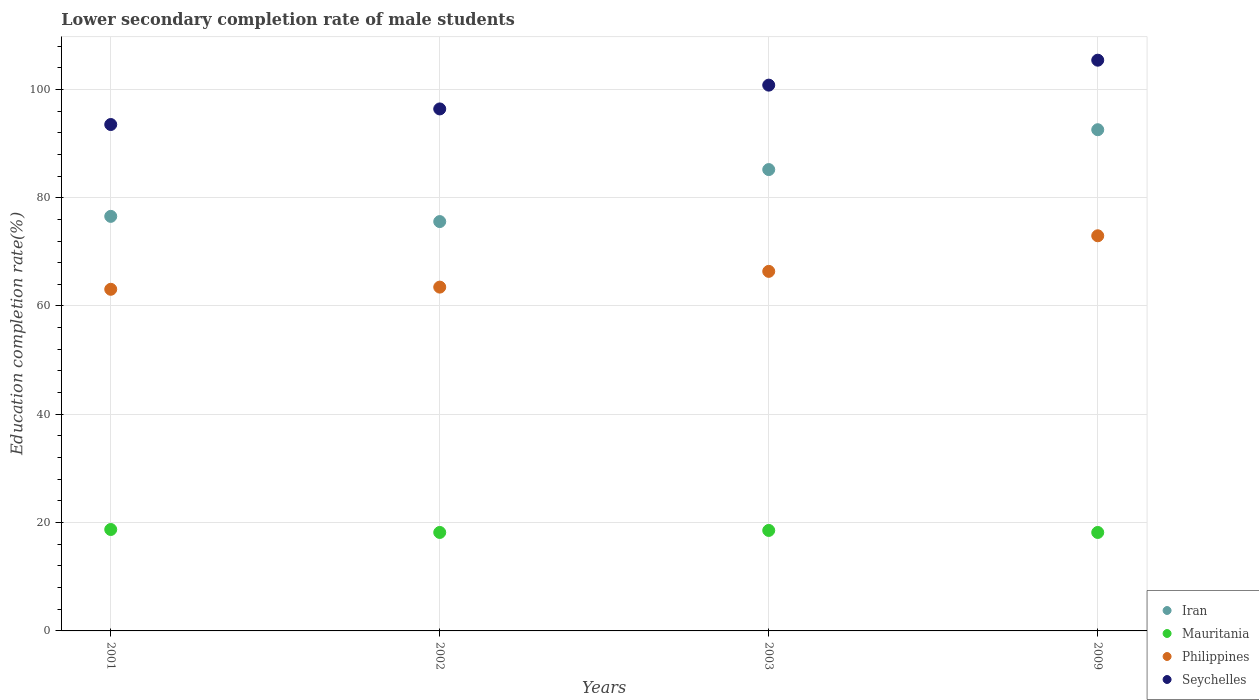Is the number of dotlines equal to the number of legend labels?
Ensure brevity in your answer.  Yes. What is the lower secondary completion rate of male students in Iran in 2002?
Offer a very short reply. 75.59. Across all years, what is the maximum lower secondary completion rate of male students in Iran?
Your response must be concise. 92.55. Across all years, what is the minimum lower secondary completion rate of male students in Iran?
Give a very brief answer. 75.59. In which year was the lower secondary completion rate of male students in Mauritania maximum?
Your response must be concise. 2001. What is the total lower secondary completion rate of male students in Mauritania in the graph?
Provide a succinct answer. 73.65. What is the difference between the lower secondary completion rate of male students in Seychelles in 2002 and that in 2003?
Ensure brevity in your answer.  -4.39. What is the difference between the lower secondary completion rate of male students in Philippines in 2001 and the lower secondary completion rate of male students in Mauritania in 2009?
Offer a very short reply. 44.9. What is the average lower secondary completion rate of male students in Philippines per year?
Ensure brevity in your answer.  66.48. In the year 2001, what is the difference between the lower secondary completion rate of male students in Mauritania and lower secondary completion rate of male students in Philippines?
Keep it short and to the point. -44.35. In how many years, is the lower secondary completion rate of male students in Seychelles greater than 84 %?
Your answer should be very brief. 4. What is the ratio of the lower secondary completion rate of male students in Mauritania in 2002 to that in 2009?
Make the answer very short. 1. Is the difference between the lower secondary completion rate of male students in Mauritania in 2002 and 2003 greater than the difference between the lower secondary completion rate of male students in Philippines in 2002 and 2003?
Provide a succinct answer. Yes. What is the difference between the highest and the second highest lower secondary completion rate of male students in Seychelles?
Offer a very short reply. 4.61. What is the difference between the highest and the lowest lower secondary completion rate of male students in Seychelles?
Provide a short and direct response. 11.88. In how many years, is the lower secondary completion rate of male students in Iran greater than the average lower secondary completion rate of male students in Iran taken over all years?
Keep it short and to the point. 2. Is it the case that in every year, the sum of the lower secondary completion rate of male students in Philippines and lower secondary completion rate of male students in Iran  is greater than the lower secondary completion rate of male students in Seychelles?
Offer a terse response. Yes. Does the lower secondary completion rate of male students in Iran monotonically increase over the years?
Your answer should be compact. No. Is the lower secondary completion rate of male students in Iran strictly greater than the lower secondary completion rate of male students in Mauritania over the years?
Offer a very short reply. Yes. Is the lower secondary completion rate of male students in Mauritania strictly less than the lower secondary completion rate of male students in Philippines over the years?
Provide a succinct answer. Yes. How many years are there in the graph?
Your response must be concise. 4. Does the graph contain any zero values?
Provide a succinct answer. No. Where does the legend appear in the graph?
Provide a succinct answer. Bottom right. How many legend labels are there?
Offer a very short reply. 4. What is the title of the graph?
Your answer should be very brief. Lower secondary completion rate of male students. What is the label or title of the X-axis?
Give a very brief answer. Years. What is the label or title of the Y-axis?
Your answer should be compact. Education completion rate(%). What is the Education completion rate(%) in Iran in 2001?
Keep it short and to the point. 76.55. What is the Education completion rate(%) of Mauritania in 2001?
Provide a succinct answer. 18.73. What is the Education completion rate(%) in Philippines in 2001?
Your response must be concise. 63.08. What is the Education completion rate(%) in Seychelles in 2001?
Your answer should be compact. 93.51. What is the Education completion rate(%) of Iran in 2002?
Offer a very short reply. 75.59. What is the Education completion rate(%) of Mauritania in 2002?
Provide a succinct answer. 18.18. What is the Education completion rate(%) in Philippines in 2002?
Keep it short and to the point. 63.49. What is the Education completion rate(%) in Seychelles in 2002?
Offer a very short reply. 96.39. What is the Education completion rate(%) of Iran in 2003?
Make the answer very short. 85.19. What is the Education completion rate(%) in Mauritania in 2003?
Your response must be concise. 18.56. What is the Education completion rate(%) of Philippines in 2003?
Provide a short and direct response. 66.39. What is the Education completion rate(%) of Seychelles in 2003?
Offer a very short reply. 100.78. What is the Education completion rate(%) of Iran in 2009?
Provide a short and direct response. 92.55. What is the Education completion rate(%) of Mauritania in 2009?
Make the answer very short. 18.18. What is the Education completion rate(%) of Philippines in 2009?
Give a very brief answer. 72.97. What is the Education completion rate(%) in Seychelles in 2009?
Offer a very short reply. 105.39. Across all years, what is the maximum Education completion rate(%) in Iran?
Your response must be concise. 92.55. Across all years, what is the maximum Education completion rate(%) in Mauritania?
Your answer should be very brief. 18.73. Across all years, what is the maximum Education completion rate(%) of Philippines?
Make the answer very short. 72.97. Across all years, what is the maximum Education completion rate(%) of Seychelles?
Offer a terse response. 105.39. Across all years, what is the minimum Education completion rate(%) of Iran?
Your response must be concise. 75.59. Across all years, what is the minimum Education completion rate(%) of Mauritania?
Your response must be concise. 18.18. Across all years, what is the minimum Education completion rate(%) of Philippines?
Provide a succinct answer. 63.08. Across all years, what is the minimum Education completion rate(%) of Seychelles?
Ensure brevity in your answer.  93.51. What is the total Education completion rate(%) of Iran in the graph?
Provide a short and direct response. 329.88. What is the total Education completion rate(%) of Mauritania in the graph?
Offer a very short reply. 73.65. What is the total Education completion rate(%) of Philippines in the graph?
Your answer should be compact. 265.93. What is the total Education completion rate(%) in Seychelles in the graph?
Ensure brevity in your answer.  396.08. What is the difference between the Education completion rate(%) of Iran in 2001 and that in 2002?
Ensure brevity in your answer.  0.96. What is the difference between the Education completion rate(%) in Mauritania in 2001 and that in 2002?
Provide a succinct answer. 0.55. What is the difference between the Education completion rate(%) in Philippines in 2001 and that in 2002?
Ensure brevity in your answer.  -0.4. What is the difference between the Education completion rate(%) of Seychelles in 2001 and that in 2002?
Your response must be concise. -2.88. What is the difference between the Education completion rate(%) of Iran in 2001 and that in 2003?
Keep it short and to the point. -8.64. What is the difference between the Education completion rate(%) of Mauritania in 2001 and that in 2003?
Your answer should be compact. 0.17. What is the difference between the Education completion rate(%) of Philippines in 2001 and that in 2003?
Ensure brevity in your answer.  -3.31. What is the difference between the Education completion rate(%) of Seychelles in 2001 and that in 2003?
Your answer should be very brief. -7.27. What is the difference between the Education completion rate(%) in Iran in 2001 and that in 2009?
Provide a succinct answer. -16. What is the difference between the Education completion rate(%) in Mauritania in 2001 and that in 2009?
Keep it short and to the point. 0.55. What is the difference between the Education completion rate(%) of Philippines in 2001 and that in 2009?
Your answer should be compact. -9.88. What is the difference between the Education completion rate(%) of Seychelles in 2001 and that in 2009?
Provide a short and direct response. -11.88. What is the difference between the Education completion rate(%) of Iran in 2002 and that in 2003?
Ensure brevity in your answer.  -9.6. What is the difference between the Education completion rate(%) in Mauritania in 2002 and that in 2003?
Offer a very short reply. -0.37. What is the difference between the Education completion rate(%) of Philippines in 2002 and that in 2003?
Your answer should be compact. -2.91. What is the difference between the Education completion rate(%) in Seychelles in 2002 and that in 2003?
Keep it short and to the point. -4.39. What is the difference between the Education completion rate(%) of Iran in 2002 and that in 2009?
Offer a very short reply. -16.96. What is the difference between the Education completion rate(%) of Mauritania in 2002 and that in 2009?
Ensure brevity in your answer.  0. What is the difference between the Education completion rate(%) of Philippines in 2002 and that in 2009?
Give a very brief answer. -9.48. What is the difference between the Education completion rate(%) of Seychelles in 2002 and that in 2009?
Make the answer very short. -9. What is the difference between the Education completion rate(%) in Iran in 2003 and that in 2009?
Make the answer very short. -7.36. What is the difference between the Education completion rate(%) of Mauritania in 2003 and that in 2009?
Provide a short and direct response. 0.38. What is the difference between the Education completion rate(%) in Philippines in 2003 and that in 2009?
Offer a terse response. -6.57. What is the difference between the Education completion rate(%) of Seychelles in 2003 and that in 2009?
Provide a succinct answer. -4.61. What is the difference between the Education completion rate(%) of Iran in 2001 and the Education completion rate(%) of Mauritania in 2002?
Give a very brief answer. 58.37. What is the difference between the Education completion rate(%) in Iran in 2001 and the Education completion rate(%) in Philippines in 2002?
Make the answer very short. 13.06. What is the difference between the Education completion rate(%) in Iran in 2001 and the Education completion rate(%) in Seychelles in 2002?
Offer a very short reply. -19.84. What is the difference between the Education completion rate(%) in Mauritania in 2001 and the Education completion rate(%) in Philippines in 2002?
Your answer should be very brief. -44.76. What is the difference between the Education completion rate(%) of Mauritania in 2001 and the Education completion rate(%) of Seychelles in 2002?
Your response must be concise. -77.66. What is the difference between the Education completion rate(%) in Philippines in 2001 and the Education completion rate(%) in Seychelles in 2002?
Your response must be concise. -33.31. What is the difference between the Education completion rate(%) in Iran in 2001 and the Education completion rate(%) in Mauritania in 2003?
Provide a succinct answer. 58. What is the difference between the Education completion rate(%) of Iran in 2001 and the Education completion rate(%) of Philippines in 2003?
Provide a short and direct response. 10.16. What is the difference between the Education completion rate(%) in Iran in 2001 and the Education completion rate(%) in Seychelles in 2003?
Provide a short and direct response. -24.23. What is the difference between the Education completion rate(%) of Mauritania in 2001 and the Education completion rate(%) of Philippines in 2003?
Provide a succinct answer. -47.66. What is the difference between the Education completion rate(%) of Mauritania in 2001 and the Education completion rate(%) of Seychelles in 2003?
Ensure brevity in your answer.  -82.06. What is the difference between the Education completion rate(%) of Philippines in 2001 and the Education completion rate(%) of Seychelles in 2003?
Your response must be concise. -37.7. What is the difference between the Education completion rate(%) of Iran in 2001 and the Education completion rate(%) of Mauritania in 2009?
Provide a succinct answer. 58.37. What is the difference between the Education completion rate(%) of Iran in 2001 and the Education completion rate(%) of Philippines in 2009?
Ensure brevity in your answer.  3.58. What is the difference between the Education completion rate(%) of Iran in 2001 and the Education completion rate(%) of Seychelles in 2009?
Your answer should be very brief. -28.84. What is the difference between the Education completion rate(%) in Mauritania in 2001 and the Education completion rate(%) in Philippines in 2009?
Ensure brevity in your answer.  -54.24. What is the difference between the Education completion rate(%) of Mauritania in 2001 and the Education completion rate(%) of Seychelles in 2009?
Make the answer very short. -86.66. What is the difference between the Education completion rate(%) in Philippines in 2001 and the Education completion rate(%) in Seychelles in 2009?
Provide a succinct answer. -42.31. What is the difference between the Education completion rate(%) of Iran in 2002 and the Education completion rate(%) of Mauritania in 2003?
Offer a terse response. 57.03. What is the difference between the Education completion rate(%) of Iran in 2002 and the Education completion rate(%) of Philippines in 2003?
Offer a very short reply. 9.2. What is the difference between the Education completion rate(%) of Iran in 2002 and the Education completion rate(%) of Seychelles in 2003?
Offer a very short reply. -25.2. What is the difference between the Education completion rate(%) in Mauritania in 2002 and the Education completion rate(%) in Philippines in 2003?
Your answer should be very brief. -48.21. What is the difference between the Education completion rate(%) in Mauritania in 2002 and the Education completion rate(%) in Seychelles in 2003?
Offer a very short reply. -82.6. What is the difference between the Education completion rate(%) in Philippines in 2002 and the Education completion rate(%) in Seychelles in 2003?
Offer a terse response. -37.3. What is the difference between the Education completion rate(%) of Iran in 2002 and the Education completion rate(%) of Mauritania in 2009?
Offer a terse response. 57.41. What is the difference between the Education completion rate(%) in Iran in 2002 and the Education completion rate(%) in Philippines in 2009?
Keep it short and to the point. 2.62. What is the difference between the Education completion rate(%) of Iran in 2002 and the Education completion rate(%) of Seychelles in 2009?
Keep it short and to the point. -29.8. What is the difference between the Education completion rate(%) of Mauritania in 2002 and the Education completion rate(%) of Philippines in 2009?
Give a very brief answer. -54.78. What is the difference between the Education completion rate(%) in Mauritania in 2002 and the Education completion rate(%) in Seychelles in 2009?
Your response must be concise. -87.21. What is the difference between the Education completion rate(%) in Philippines in 2002 and the Education completion rate(%) in Seychelles in 2009?
Ensure brevity in your answer.  -41.9. What is the difference between the Education completion rate(%) of Iran in 2003 and the Education completion rate(%) of Mauritania in 2009?
Provide a succinct answer. 67.01. What is the difference between the Education completion rate(%) in Iran in 2003 and the Education completion rate(%) in Philippines in 2009?
Your answer should be very brief. 12.23. What is the difference between the Education completion rate(%) of Iran in 2003 and the Education completion rate(%) of Seychelles in 2009?
Your answer should be very brief. -20.2. What is the difference between the Education completion rate(%) in Mauritania in 2003 and the Education completion rate(%) in Philippines in 2009?
Give a very brief answer. -54.41. What is the difference between the Education completion rate(%) of Mauritania in 2003 and the Education completion rate(%) of Seychelles in 2009?
Keep it short and to the point. -86.83. What is the difference between the Education completion rate(%) in Philippines in 2003 and the Education completion rate(%) in Seychelles in 2009?
Keep it short and to the point. -39. What is the average Education completion rate(%) in Iran per year?
Your answer should be very brief. 82.47. What is the average Education completion rate(%) in Mauritania per year?
Provide a short and direct response. 18.41. What is the average Education completion rate(%) in Philippines per year?
Keep it short and to the point. 66.48. What is the average Education completion rate(%) of Seychelles per year?
Give a very brief answer. 99.02. In the year 2001, what is the difference between the Education completion rate(%) in Iran and Education completion rate(%) in Mauritania?
Provide a short and direct response. 57.82. In the year 2001, what is the difference between the Education completion rate(%) of Iran and Education completion rate(%) of Philippines?
Provide a short and direct response. 13.47. In the year 2001, what is the difference between the Education completion rate(%) in Iran and Education completion rate(%) in Seychelles?
Provide a short and direct response. -16.96. In the year 2001, what is the difference between the Education completion rate(%) of Mauritania and Education completion rate(%) of Philippines?
Your response must be concise. -44.35. In the year 2001, what is the difference between the Education completion rate(%) in Mauritania and Education completion rate(%) in Seychelles?
Offer a terse response. -74.78. In the year 2001, what is the difference between the Education completion rate(%) in Philippines and Education completion rate(%) in Seychelles?
Give a very brief answer. -30.43. In the year 2002, what is the difference between the Education completion rate(%) of Iran and Education completion rate(%) of Mauritania?
Offer a terse response. 57.41. In the year 2002, what is the difference between the Education completion rate(%) of Iran and Education completion rate(%) of Philippines?
Give a very brief answer. 12.1. In the year 2002, what is the difference between the Education completion rate(%) in Iran and Education completion rate(%) in Seychelles?
Ensure brevity in your answer.  -20.8. In the year 2002, what is the difference between the Education completion rate(%) of Mauritania and Education completion rate(%) of Philippines?
Provide a short and direct response. -45.3. In the year 2002, what is the difference between the Education completion rate(%) in Mauritania and Education completion rate(%) in Seychelles?
Provide a short and direct response. -78.21. In the year 2002, what is the difference between the Education completion rate(%) of Philippines and Education completion rate(%) of Seychelles?
Provide a short and direct response. -32.91. In the year 2003, what is the difference between the Education completion rate(%) of Iran and Education completion rate(%) of Mauritania?
Give a very brief answer. 66.64. In the year 2003, what is the difference between the Education completion rate(%) of Iran and Education completion rate(%) of Philippines?
Your answer should be compact. 18.8. In the year 2003, what is the difference between the Education completion rate(%) of Iran and Education completion rate(%) of Seychelles?
Provide a succinct answer. -15.59. In the year 2003, what is the difference between the Education completion rate(%) of Mauritania and Education completion rate(%) of Philippines?
Provide a succinct answer. -47.84. In the year 2003, what is the difference between the Education completion rate(%) of Mauritania and Education completion rate(%) of Seychelles?
Offer a terse response. -82.23. In the year 2003, what is the difference between the Education completion rate(%) of Philippines and Education completion rate(%) of Seychelles?
Your response must be concise. -34.39. In the year 2009, what is the difference between the Education completion rate(%) in Iran and Education completion rate(%) in Mauritania?
Your answer should be very brief. 74.37. In the year 2009, what is the difference between the Education completion rate(%) in Iran and Education completion rate(%) in Philippines?
Keep it short and to the point. 19.59. In the year 2009, what is the difference between the Education completion rate(%) in Iran and Education completion rate(%) in Seychelles?
Provide a short and direct response. -12.84. In the year 2009, what is the difference between the Education completion rate(%) of Mauritania and Education completion rate(%) of Philippines?
Provide a succinct answer. -54.79. In the year 2009, what is the difference between the Education completion rate(%) in Mauritania and Education completion rate(%) in Seychelles?
Your answer should be very brief. -87.21. In the year 2009, what is the difference between the Education completion rate(%) of Philippines and Education completion rate(%) of Seychelles?
Keep it short and to the point. -32.42. What is the ratio of the Education completion rate(%) in Iran in 2001 to that in 2002?
Your answer should be compact. 1.01. What is the ratio of the Education completion rate(%) of Mauritania in 2001 to that in 2002?
Give a very brief answer. 1.03. What is the ratio of the Education completion rate(%) of Philippines in 2001 to that in 2002?
Provide a short and direct response. 0.99. What is the ratio of the Education completion rate(%) in Seychelles in 2001 to that in 2002?
Provide a succinct answer. 0.97. What is the ratio of the Education completion rate(%) in Iran in 2001 to that in 2003?
Provide a succinct answer. 0.9. What is the ratio of the Education completion rate(%) in Mauritania in 2001 to that in 2003?
Give a very brief answer. 1.01. What is the ratio of the Education completion rate(%) of Philippines in 2001 to that in 2003?
Offer a very short reply. 0.95. What is the ratio of the Education completion rate(%) of Seychelles in 2001 to that in 2003?
Offer a terse response. 0.93. What is the ratio of the Education completion rate(%) in Iran in 2001 to that in 2009?
Provide a short and direct response. 0.83. What is the ratio of the Education completion rate(%) of Mauritania in 2001 to that in 2009?
Your answer should be very brief. 1.03. What is the ratio of the Education completion rate(%) of Philippines in 2001 to that in 2009?
Give a very brief answer. 0.86. What is the ratio of the Education completion rate(%) of Seychelles in 2001 to that in 2009?
Offer a terse response. 0.89. What is the ratio of the Education completion rate(%) of Iran in 2002 to that in 2003?
Give a very brief answer. 0.89. What is the ratio of the Education completion rate(%) of Mauritania in 2002 to that in 2003?
Give a very brief answer. 0.98. What is the ratio of the Education completion rate(%) in Philippines in 2002 to that in 2003?
Your answer should be very brief. 0.96. What is the ratio of the Education completion rate(%) of Seychelles in 2002 to that in 2003?
Ensure brevity in your answer.  0.96. What is the ratio of the Education completion rate(%) in Iran in 2002 to that in 2009?
Offer a terse response. 0.82. What is the ratio of the Education completion rate(%) in Mauritania in 2002 to that in 2009?
Your answer should be very brief. 1. What is the ratio of the Education completion rate(%) in Philippines in 2002 to that in 2009?
Make the answer very short. 0.87. What is the ratio of the Education completion rate(%) in Seychelles in 2002 to that in 2009?
Your answer should be very brief. 0.91. What is the ratio of the Education completion rate(%) in Iran in 2003 to that in 2009?
Offer a terse response. 0.92. What is the ratio of the Education completion rate(%) in Mauritania in 2003 to that in 2009?
Ensure brevity in your answer.  1.02. What is the ratio of the Education completion rate(%) in Philippines in 2003 to that in 2009?
Your response must be concise. 0.91. What is the ratio of the Education completion rate(%) in Seychelles in 2003 to that in 2009?
Keep it short and to the point. 0.96. What is the difference between the highest and the second highest Education completion rate(%) in Iran?
Offer a terse response. 7.36. What is the difference between the highest and the second highest Education completion rate(%) in Mauritania?
Give a very brief answer. 0.17. What is the difference between the highest and the second highest Education completion rate(%) of Philippines?
Your answer should be compact. 6.57. What is the difference between the highest and the second highest Education completion rate(%) in Seychelles?
Your answer should be very brief. 4.61. What is the difference between the highest and the lowest Education completion rate(%) of Iran?
Keep it short and to the point. 16.96. What is the difference between the highest and the lowest Education completion rate(%) in Mauritania?
Offer a terse response. 0.55. What is the difference between the highest and the lowest Education completion rate(%) of Philippines?
Provide a short and direct response. 9.88. What is the difference between the highest and the lowest Education completion rate(%) in Seychelles?
Offer a very short reply. 11.88. 